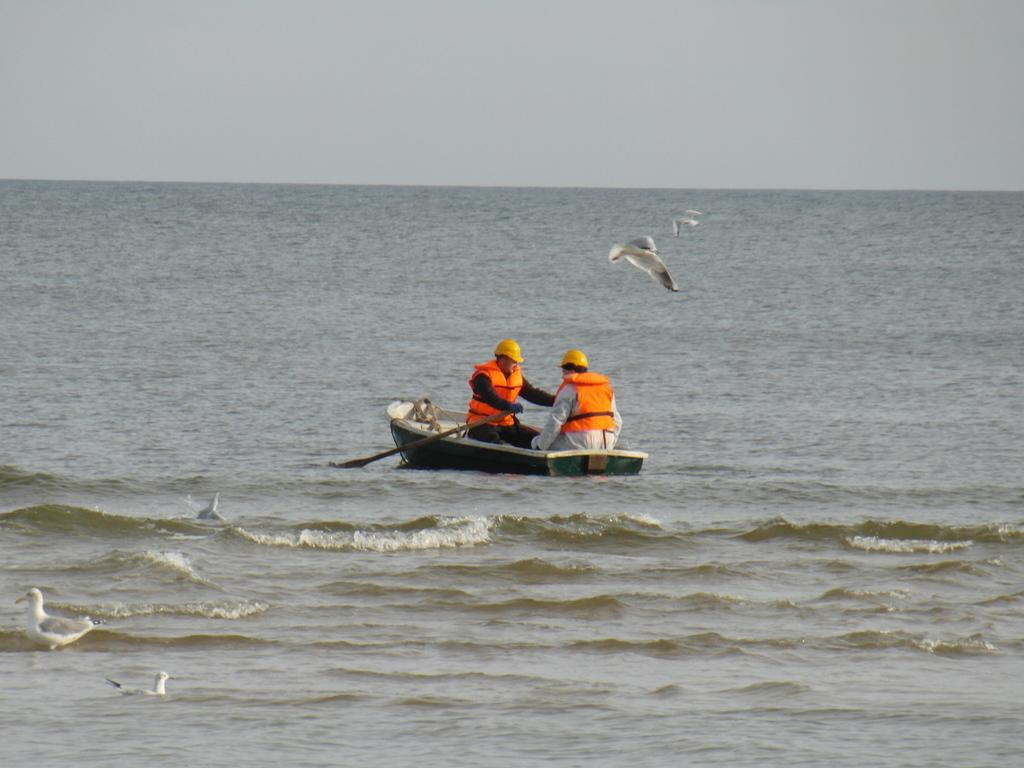What activity are the people in the image engaged in? The people in the image are rowing a boat. What type of water body is present in the image? There is a sea in the image. What other living creatures can be seen in the image? There are birds in the image. What part of the natural environment is visible in the image? The sky is visible in the image. What arithmetic problem can be solved using the numbers on the boat? There is there a pot in the image? 